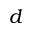<formula> <loc_0><loc_0><loc_500><loc_500>d</formula> 